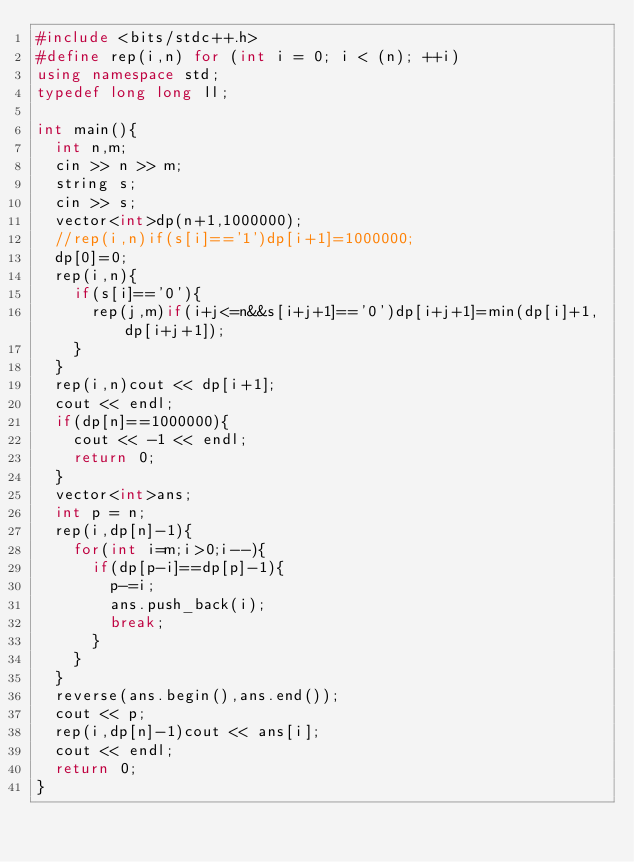<code> <loc_0><loc_0><loc_500><loc_500><_C++_>#include <bits/stdc++.h>
#define rep(i,n) for (int i = 0; i < (n); ++i)
using namespace std;
typedef long long ll;

int main(){
  int n,m;
  cin >> n >> m;
  string s;
  cin >> s;
  vector<int>dp(n+1,1000000);
  //rep(i,n)if(s[i]=='1')dp[i+1]=1000000;
  dp[0]=0;
  rep(i,n){
    if(s[i]=='0'){
      rep(j,m)if(i+j<=n&&s[i+j+1]=='0')dp[i+j+1]=min(dp[i]+1,dp[i+j+1]);
    }
  }
  rep(i,n)cout << dp[i+1];
  cout << endl;
  if(dp[n]==1000000){
    cout << -1 << endl;
    return 0;
  }
  vector<int>ans;
  int p = n;
  rep(i,dp[n]-1){
    for(int i=m;i>0;i--){
      if(dp[p-i]==dp[p]-1){
        p-=i;
        ans.push_back(i);
        break;
      }
    }
  }
  reverse(ans.begin(),ans.end());
  cout << p;
  rep(i,dp[n]-1)cout << ans[i];
  cout << endl;
  return 0;
}
</code> 